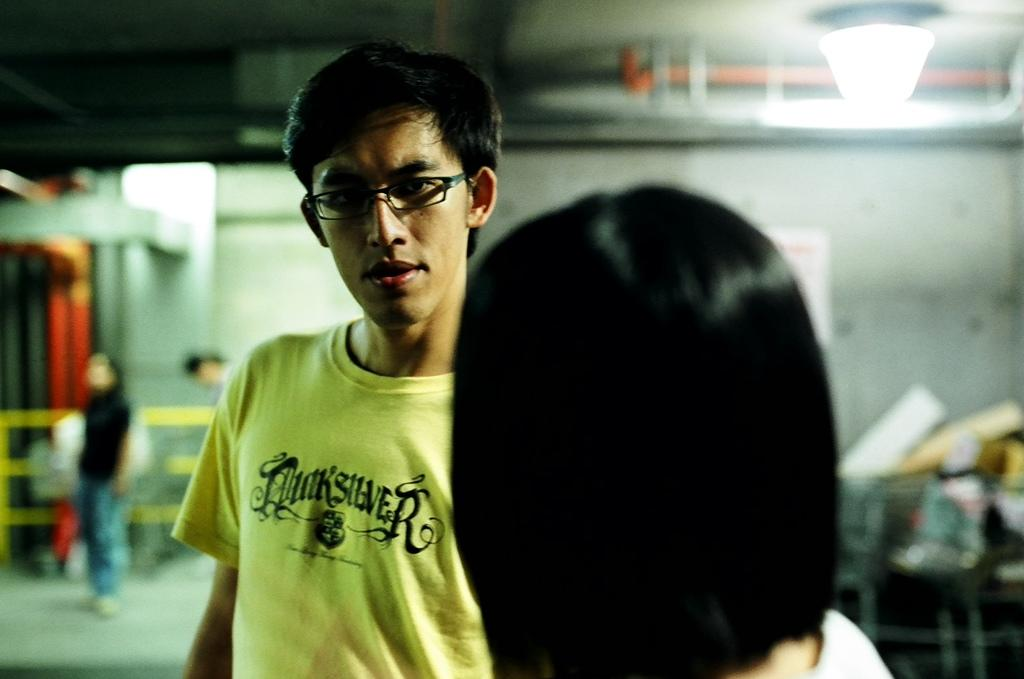How many people are in the image? There is a group of people in the image. Can you describe the man in the middle of the image? The man in the middle of the image is wearing spectacles. What can be seen in the background of the image? There are lights, pipes, and other unspecified objects visible in the background of the image. What type of volleyball is being played by the horses in the image? There are no horses or volleyball present in the image. What is the porter carrying in the image? There is no porter present in the image. 